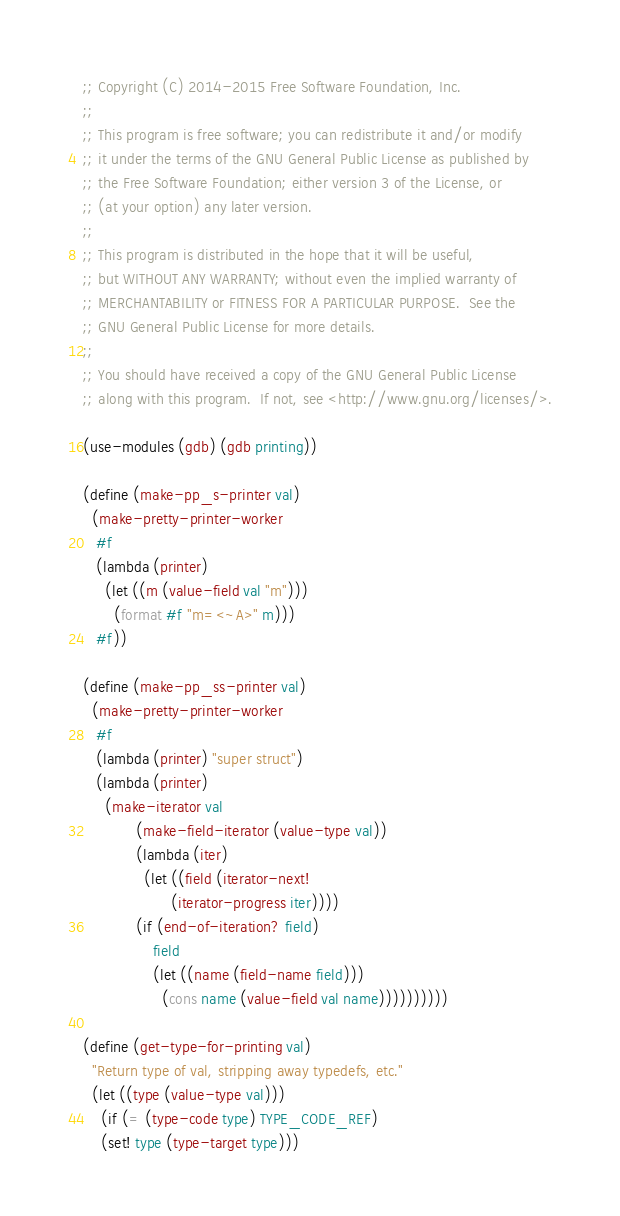Convert code to text. <code><loc_0><loc_0><loc_500><loc_500><_Scheme_>;; Copyright (C) 2014-2015 Free Software Foundation, Inc.
;;
;; This program is free software; you can redistribute it and/or modify
;; it under the terms of the GNU General Public License as published by
;; the Free Software Foundation; either version 3 of the License, or
;; (at your option) any later version.
;;
;; This program is distributed in the hope that it will be useful,
;; but WITHOUT ANY WARRANTY; without even the implied warranty of
;; MERCHANTABILITY or FITNESS FOR A PARTICULAR PURPOSE.  See the
;; GNU General Public License for more details.
;;
;; You should have received a copy of the GNU General Public License
;; along with this program.  If not, see <http://www.gnu.org/licenses/>.

(use-modules (gdb) (gdb printing))

(define (make-pp_s-printer val)
  (make-pretty-printer-worker
   #f
   (lambda (printer)
     (let ((m (value-field val "m")))
       (format #f "m=<~A>" m)))
   #f))

(define (make-pp_ss-printer val)
  (make-pretty-printer-worker
   #f
   (lambda (printer) "super struct")
   (lambda (printer)
     (make-iterator val
		    (make-field-iterator (value-type val))
		    (lambda (iter)
		      (let ((field (iterator-next!
				    (iterator-progress iter))))
			(if (end-of-iteration? field)
			    field
			    (let ((name (field-name field)))
			      (cons name (value-field val name))))))))))

(define (get-type-for-printing val)
  "Return type of val, stripping away typedefs, etc."
  (let ((type (value-type val)))
    (if (= (type-code type) TYPE_CODE_REF)
	(set! type (type-target type)))</code> 